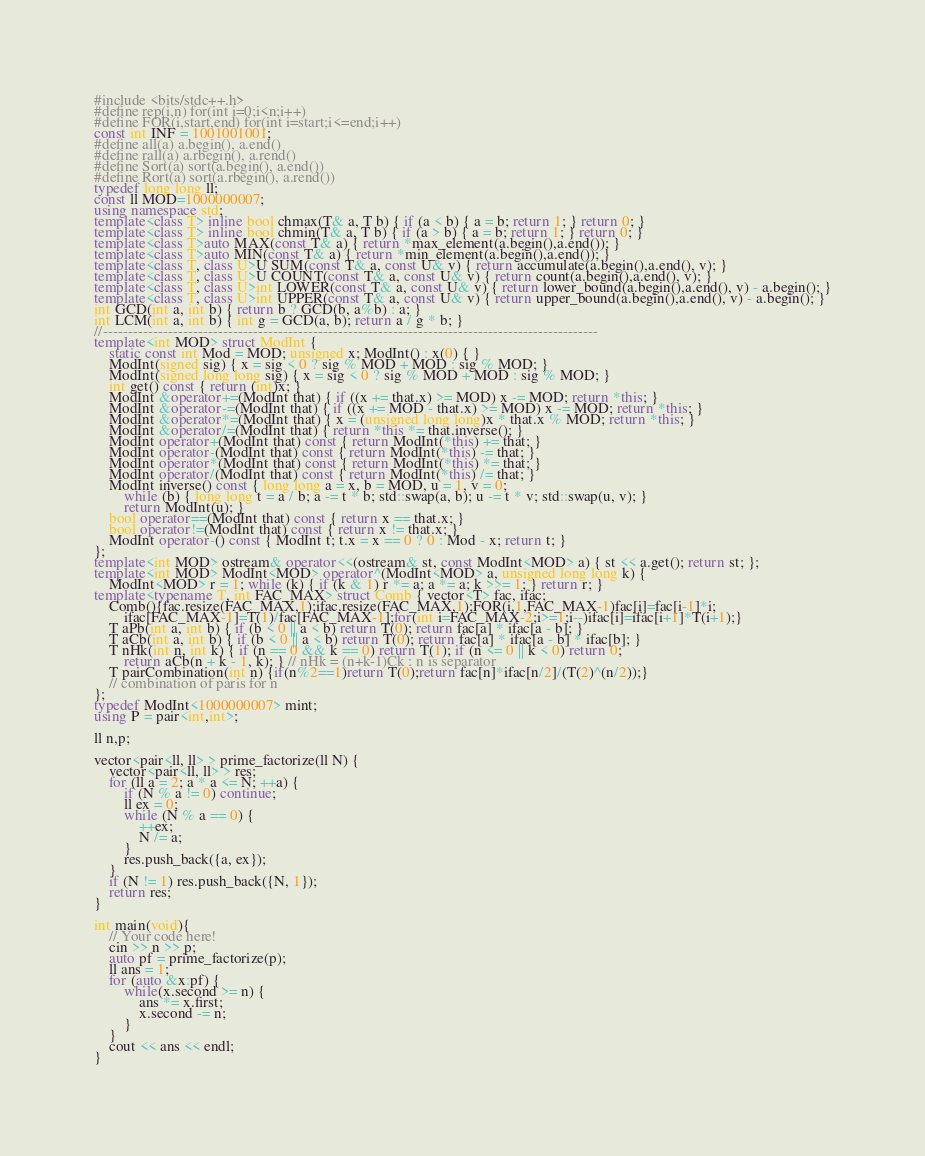<code> <loc_0><loc_0><loc_500><loc_500><_C++_>#include <bits/stdc++.h>
#define rep(i,n) for(int i=0;i<n;i++)
#define FOR(i,start,end) for(int i=start;i<=end;i++)
const int INF = 1001001001;
#define all(a) a.begin(), a.end()
#define rall(a) a.rbegin(), a.rend()
#define Sort(a) sort(a.begin(), a.end())
#define Rort(a) sort(a.rbegin(), a.rend())
typedef long long ll;
const ll MOD=1000000007;
using namespace std;
template<class T> inline bool chmax(T& a, T b) { if (a < b) { a = b; return 1; } return 0; }
template<class T> inline bool chmin(T& a, T b) { if (a > b) { a = b; return 1; } return 0; }
template<class T>auto MAX(const T& a) { return *max_element(a.begin(),a.end()); }
template<class T>auto MIN(const T& a) { return *min_element(a.begin(),a.end()); }
template<class T, class U>U SUM(const T& a, const U& v) { return accumulate(a.begin(),a.end(), v); }
template<class T, class U>U COUNT(const T& a, const U& v) { return count(a.begin(),a.end(), v); }
template<class T, class U>int LOWER(const T& a, const U& v) { return lower_bound(a.begin(),a.end(), v) - a.begin(); }
template<class T, class U>int UPPER(const T& a, const U& v) { return upper_bound(a.begin(),a.end(), v) - a.begin(); }
int GCD(int a, int b) { return b ? GCD(b, a%b) : a; }
int LCM(int a, int b) { int g = GCD(a, b); return a / g * b; }
//---------------------------------------------------------------------------------------------------
template<int MOD> struct ModInt {
    static const int Mod = MOD; unsigned x; ModInt() : x(0) { }
    ModInt(signed sig) { x = sig < 0 ? sig % MOD + MOD : sig % MOD; }
    ModInt(signed long long sig) { x = sig < 0 ? sig % MOD + MOD : sig % MOD; }
    int get() const { return (int)x; }
    ModInt &operator+=(ModInt that) { if ((x += that.x) >= MOD) x -= MOD; return *this; }
    ModInt &operator-=(ModInt that) { if ((x += MOD - that.x) >= MOD) x -= MOD; return *this; }
    ModInt &operator*=(ModInt that) { x = (unsigned long long)x * that.x % MOD; return *this; }
    ModInt &operator/=(ModInt that) { return *this *= that.inverse(); }
    ModInt operator+(ModInt that) const { return ModInt(*this) += that; }
    ModInt operator-(ModInt that) const { return ModInt(*this) -= that; }
    ModInt operator*(ModInt that) const { return ModInt(*this) *= that; }
    ModInt operator/(ModInt that) const { return ModInt(*this) /= that; }
    ModInt inverse() const { long long a = x, b = MOD, u = 1, v = 0;
        while (b) { long long t = a / b; a -= t * b; std::swap(a, b); u -= t * v; std::swap(u, v); }
        return ModInt(u); }
    bool operator==(ModInt that) const { return x == that.x; }
    bool operator!=(ModInt that) const { return x != that.x; }
    ModInt operator-() const { ModInt t; t.x = x == 0 ? 0 : Mod - x; return t; }
};
template<int MOD> ostream& operator<<(ostream& st, const ModInt<MOD> a) { st << a.get(); return st; };
template<int MOD> ModInt<MOD> operator^(ModInt<MOD> a, unsigned long long k) {
    ModInt<MOD> r = 1; while (k) { if (k & 1) r *= a; a *= a; k >>= 1; } return r; }
template<typename T, int FAC_MAX> struct Comb { vector<T> fac, ifac;
    Comb(){fac.resize(FAC_MAX,1);ifac.resize(FAC_MAX,1);FOR(i,1,FAC_MAX-1)fac[i]=fac[i-1]*i;
        ifac[FAC_MAX-1]=T(1)/fac[FAC_MAX-1];for(int i=FAC_MAX-2;i>=1;i--)ifac[i]=ifac[i+1]*T(i+1);}
    T aPb(int a, int b) { if (b < 0 || a < b) return T(0); return fac[a] * ifac[a - b]; }
    T aCb(int a, int b) { if (b < 0 || a < b) return T(0); return fac[a] * ifac[a - b] * ifac[b]; }
    T nHk(int n, int k) { if (n == 0 && k == 0) return T(1); if (n <= 0 || k < 0) return 0;
        return aCb(n + k - 1, k); } // nHk = (n+k-1)Ck : n is separator
    T pairCombination(int n) {if(n%2==1)return T(0);return fac[n]*ifac[n/2]/(T(2)^(n/2));}
    // combination of paris for n
}; 
typedef ModInt<1000000007> mint;
using P = pair<int,int>;

ll n,p;

vector<pair<ll, ll> > prime_factorize(ll N) {
    vector<pair<ll, ll> > res;
    for (ll a = 2; a * a <= N; ++a) {
        if (N % a != 0) continue;
        ll ex = 0;
        while (N % a == 0) {
            ++ex;
            N /= a;
        }
        res.push_back({a, ex});
    }
    if (N != 1) res.push_back({N, 1});
    return res;
}

int main(void){
    // Your code here!
    cin >> n >> p;
    auto pf = prime_factorize(p);
    ll ans = 1;
    for (auto &x:pf) {   
        while(x.second >= n) {
            ans *= x.first;
            x.second -= n;
        }
    }
    cout << ans << endl;
}
</code> 